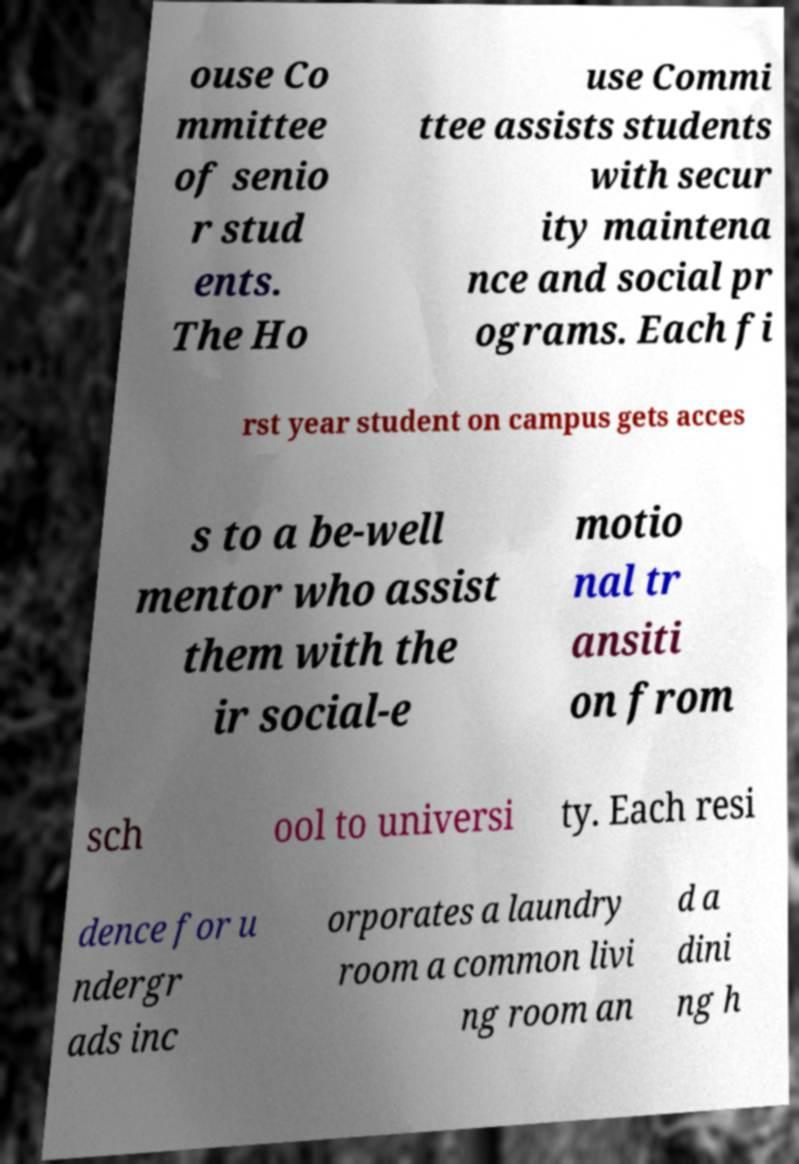Can you accurately transcribe the text from the provided image for me? ouse Co mmittee of senio r stud ents. The Ho use Commi ttee assists students with secur ity maintena nce and social pr ograms. Each fi rst year student on campus gets acces s to a be-well mentor who assist them with the ir social-e motio nal tr ansiti on from sch ool to universi ty. Each resi dence for u ndergr ads inc orporates a laundry room a common livi ng room an d a dini ng h 